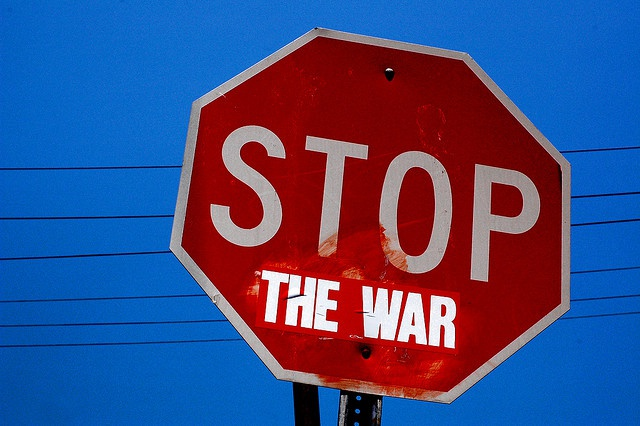Describe the objects in this image and their specific colors. I can see a stop sign in blue, maroon, darkgray, and white tones in this image. 